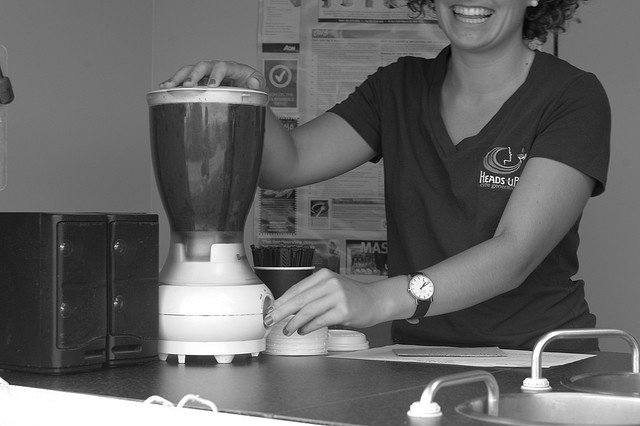Describe the objects in this image and their specific colors. I can see people in gray, black, and gainsboro tones, sink in gray, darkgray, lightgray, and black tones, and clock in gray, white, darkgray, and black tones in this image. 